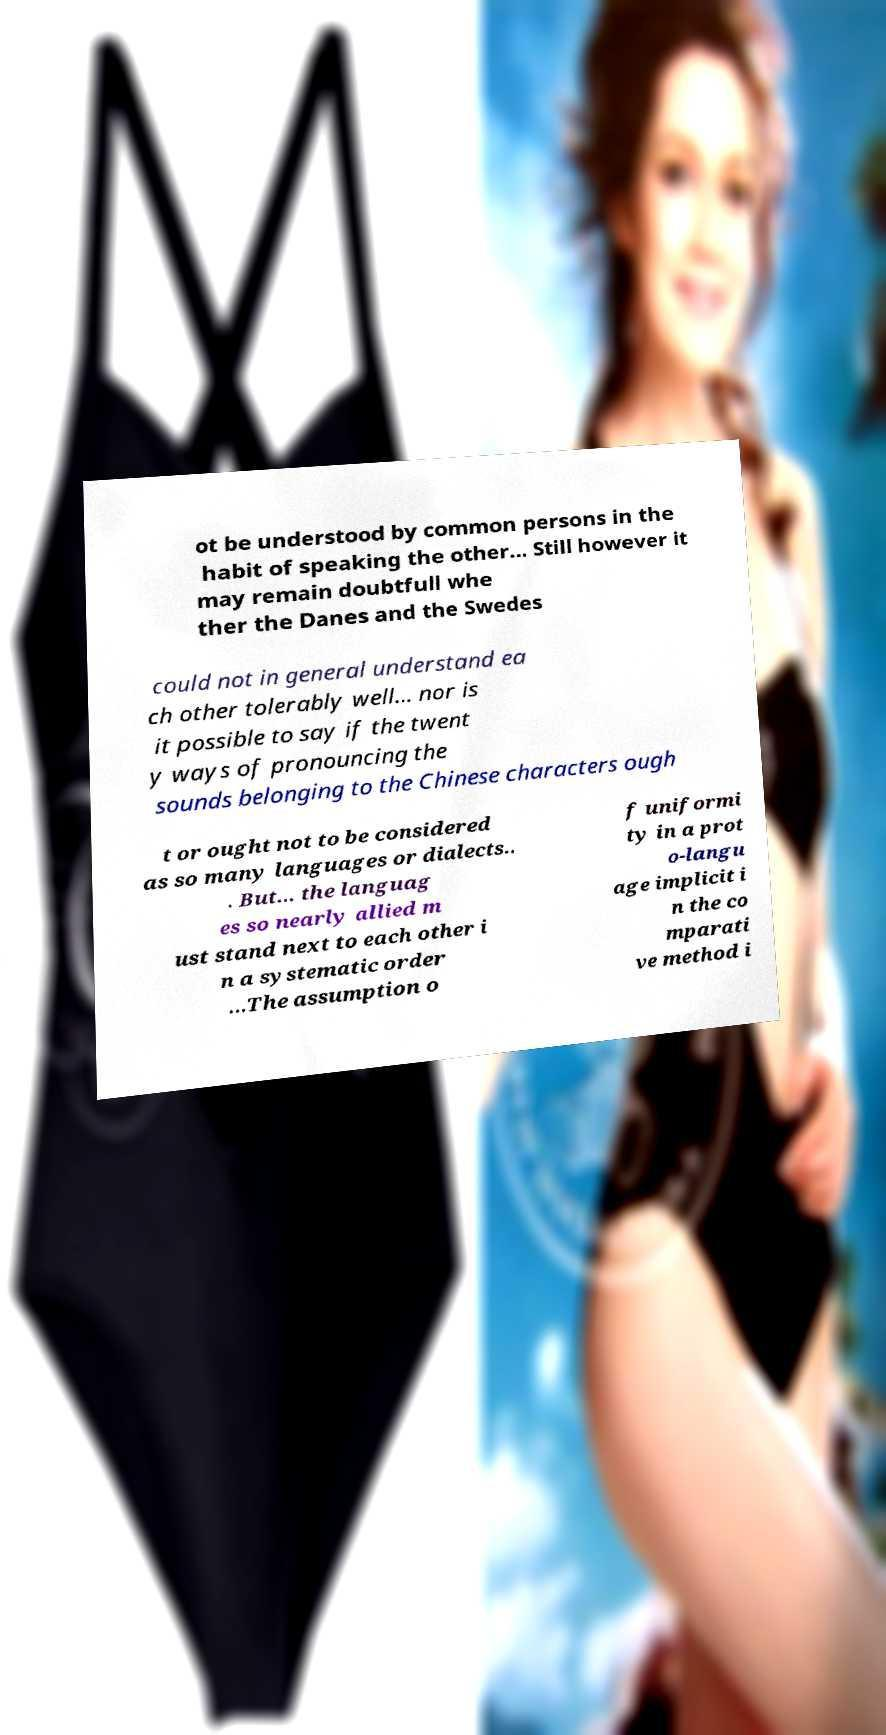What messages or text are displayed in this image? I need them in a readable, typed format. ot be understood by common persons in the habit of speaking the other... Still however it may remain doubtfull whe ther the Danes and the Swedes could not in general understand ea ch other tolerably well... nor is it possible to say if the twent y ways of pronouncing the sounds belonging to the Chinese characters ough t or ought not to be considered as so many languages or dialects.. . But... the languag es so nearly allied m ust stand next to each other i n a systematic order …The assumption o f uniformi ty in a prot o-langu age implicit i n the co mparati ve method i 